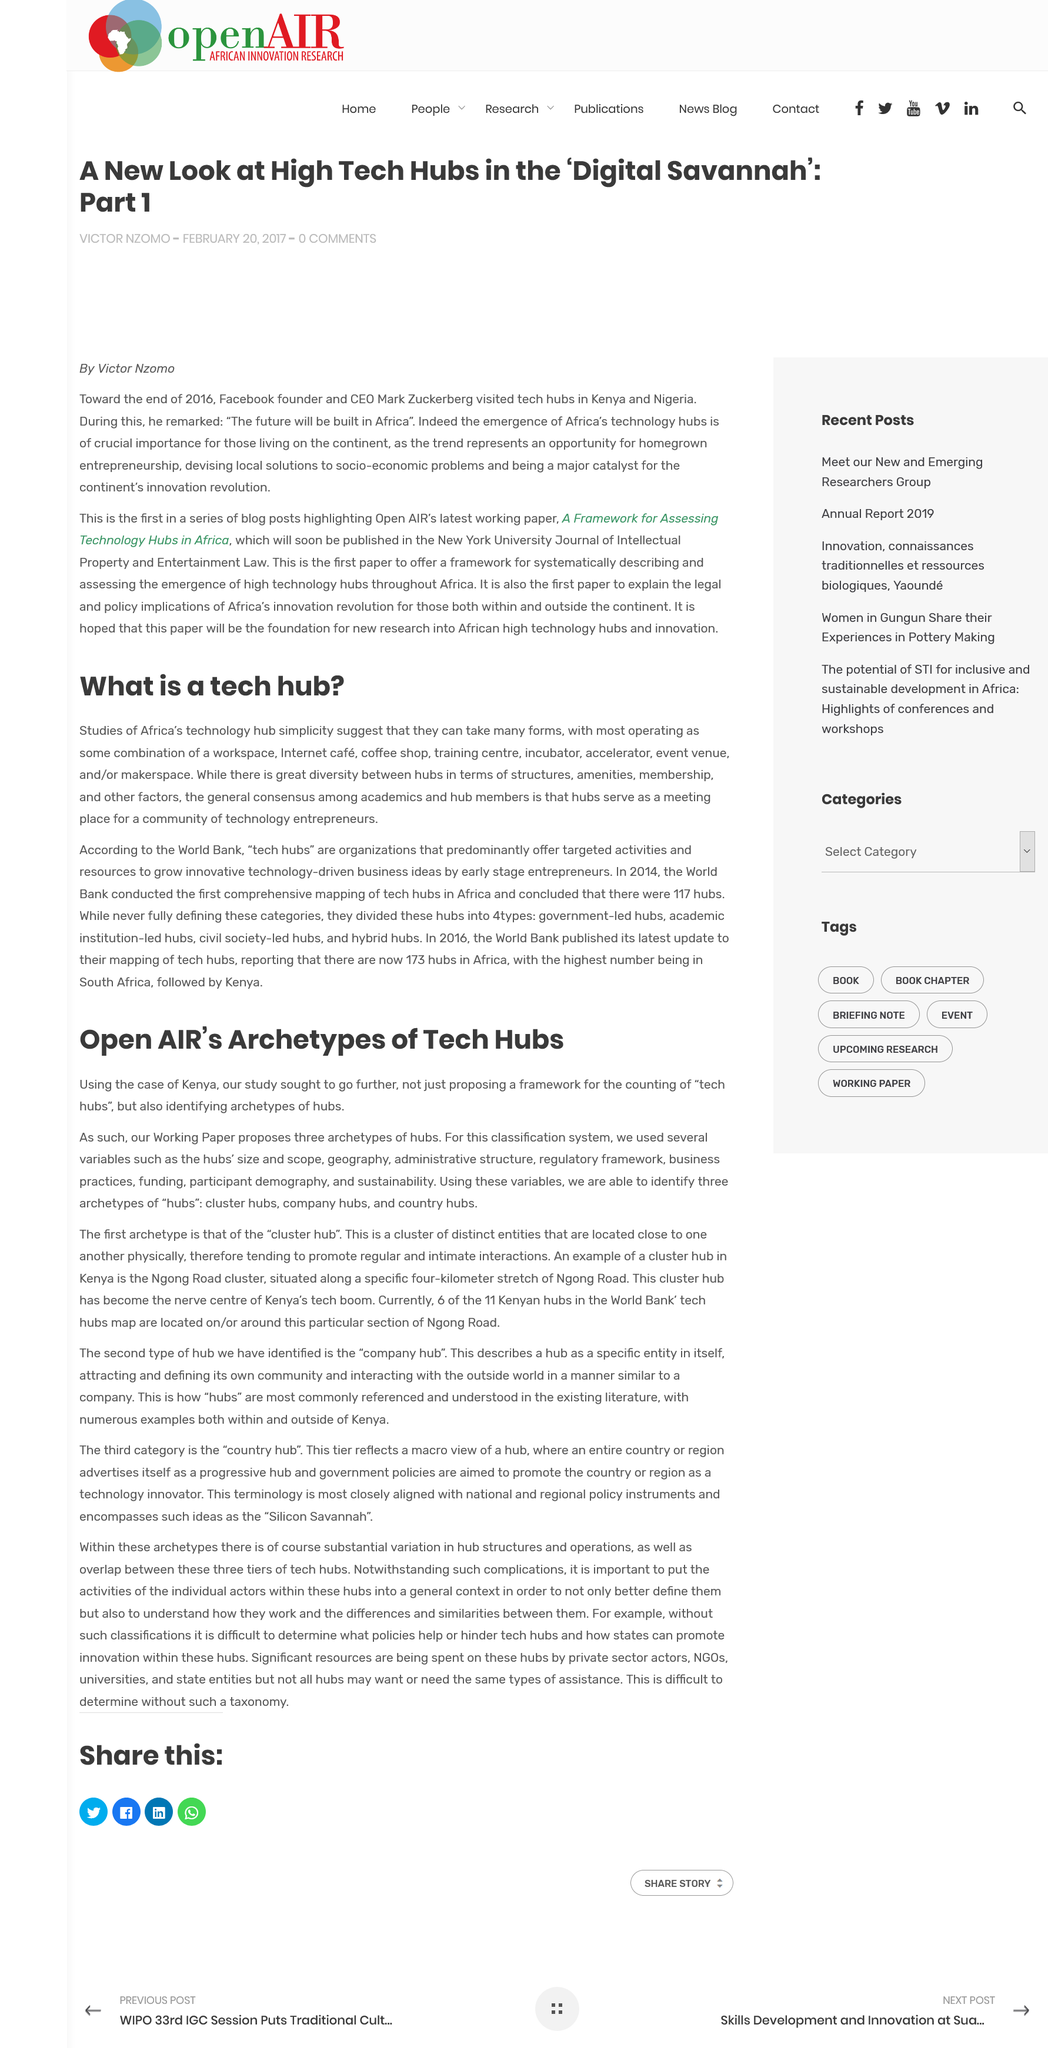Indicate a few pertinent items in this graphic. Coffee shops and training centers could potentially serve as tech hubs in Africa, as they are included among the listed forms of tech hubs. The proposed Working Paper suggests the existence of three archetypes of hubs. Kenya is used as an example to identify archetypes of hubs in the country. Tech hubs in Africa serve as a gathering place for a community of technology entrepreneurs, with the general consensus being that they serve to foster innovation and promote economic growth through the development of technology-based industries. Hubs are classified into three archetypes: cluster hubs, company hubs, and country hubs. 